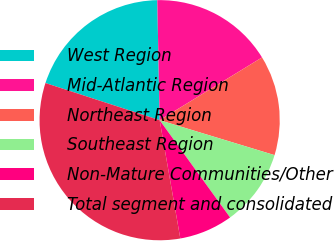<chart> <loc_0><loc_0><loc_500><loc_500><pie_chart><fcel>West Region<fcel>Mid-Atlantic Region<fcel>Northeast Region<fcel>Southeast Region<fcel>Non-Mature Communities/Other<fcel>Total segment and consolidated<nl><fcel>19.68%<fcel>16.56%<fcel>13.45%<fcel>10.33%<fcel>7.22%<fcel>32.76%<nl></chart> 